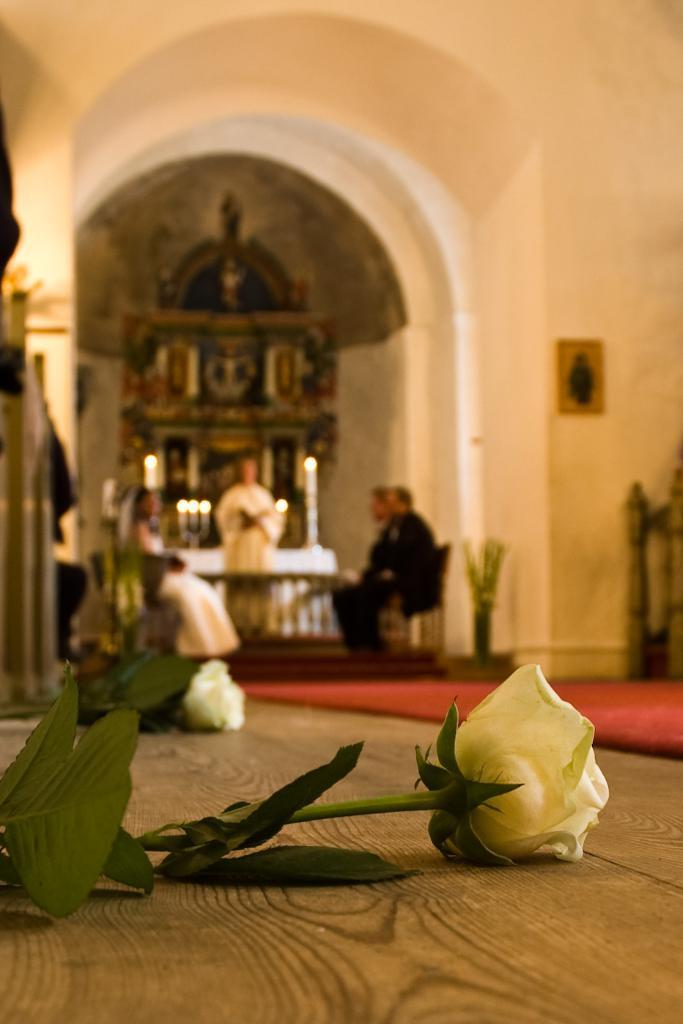What type of flowers are on the floor in the image? There are white roses with leaves on the floor. What type of floor covering is visible in the image? There is a red carpet. Can you describe the background of the image? The background is blurred. What objects can be seen in the background? There are candles in the background. Are there any people visible in the image? Yes, there are people in the background. How many cushions are on the sofa in the image? There is no sofa present in the image. What type of salt is sprinkled on the white roses in the image? There is no salt present on the white roses in the image. 